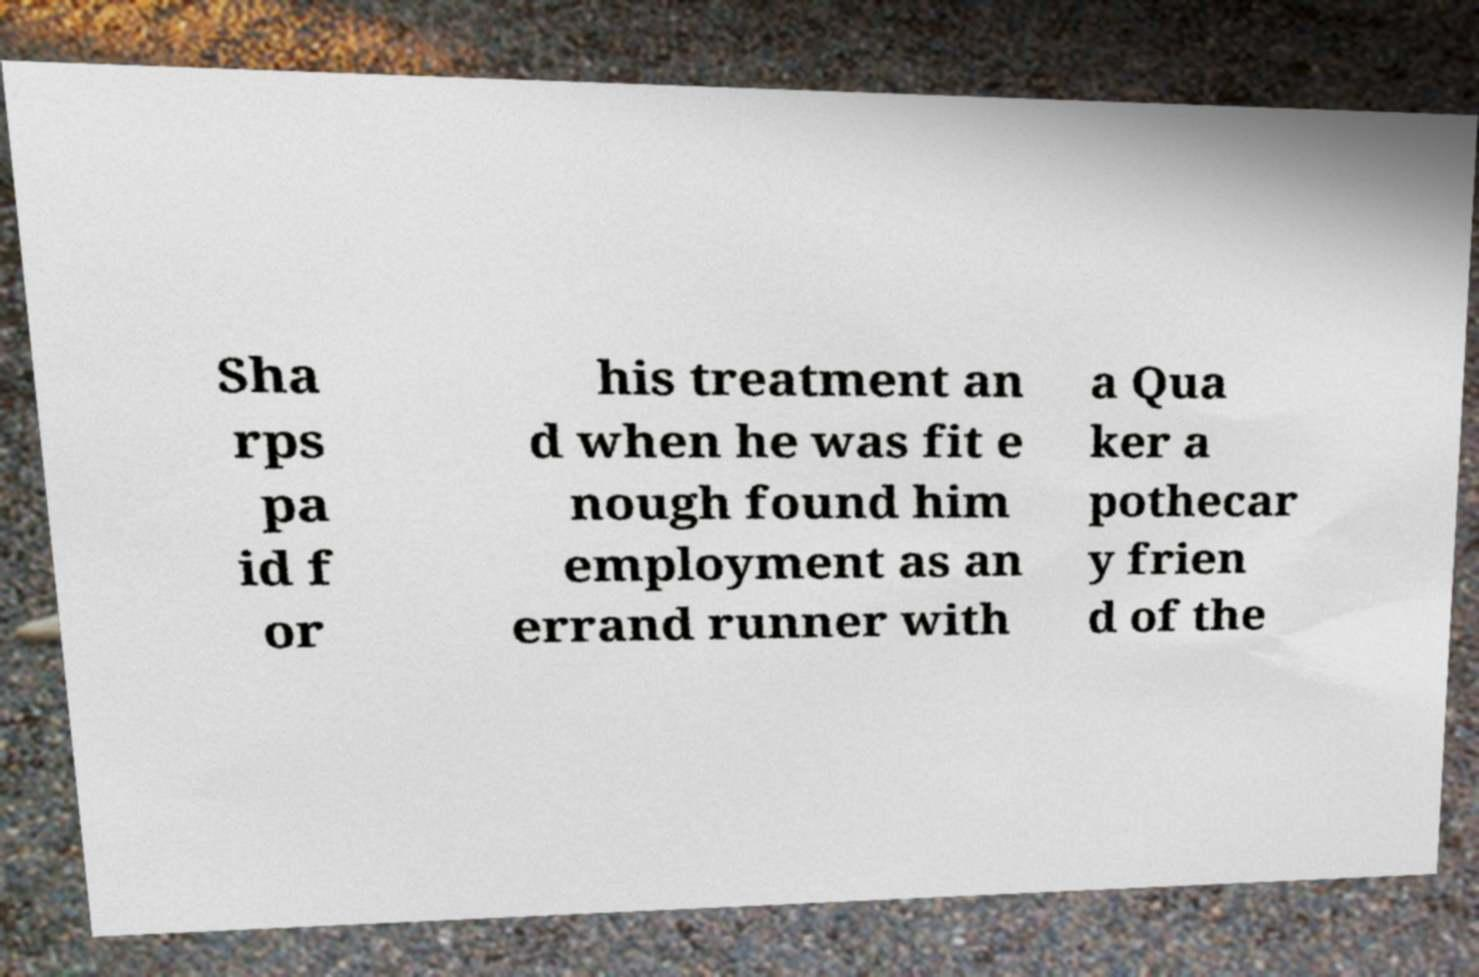What messages or text are displayed in this image? I need them in a readable, typed format. Sha rps pa id f or his treatment an d when he was fit e nough found him employment as an errand runner with a Qua ker a pothecar y frien d of the 